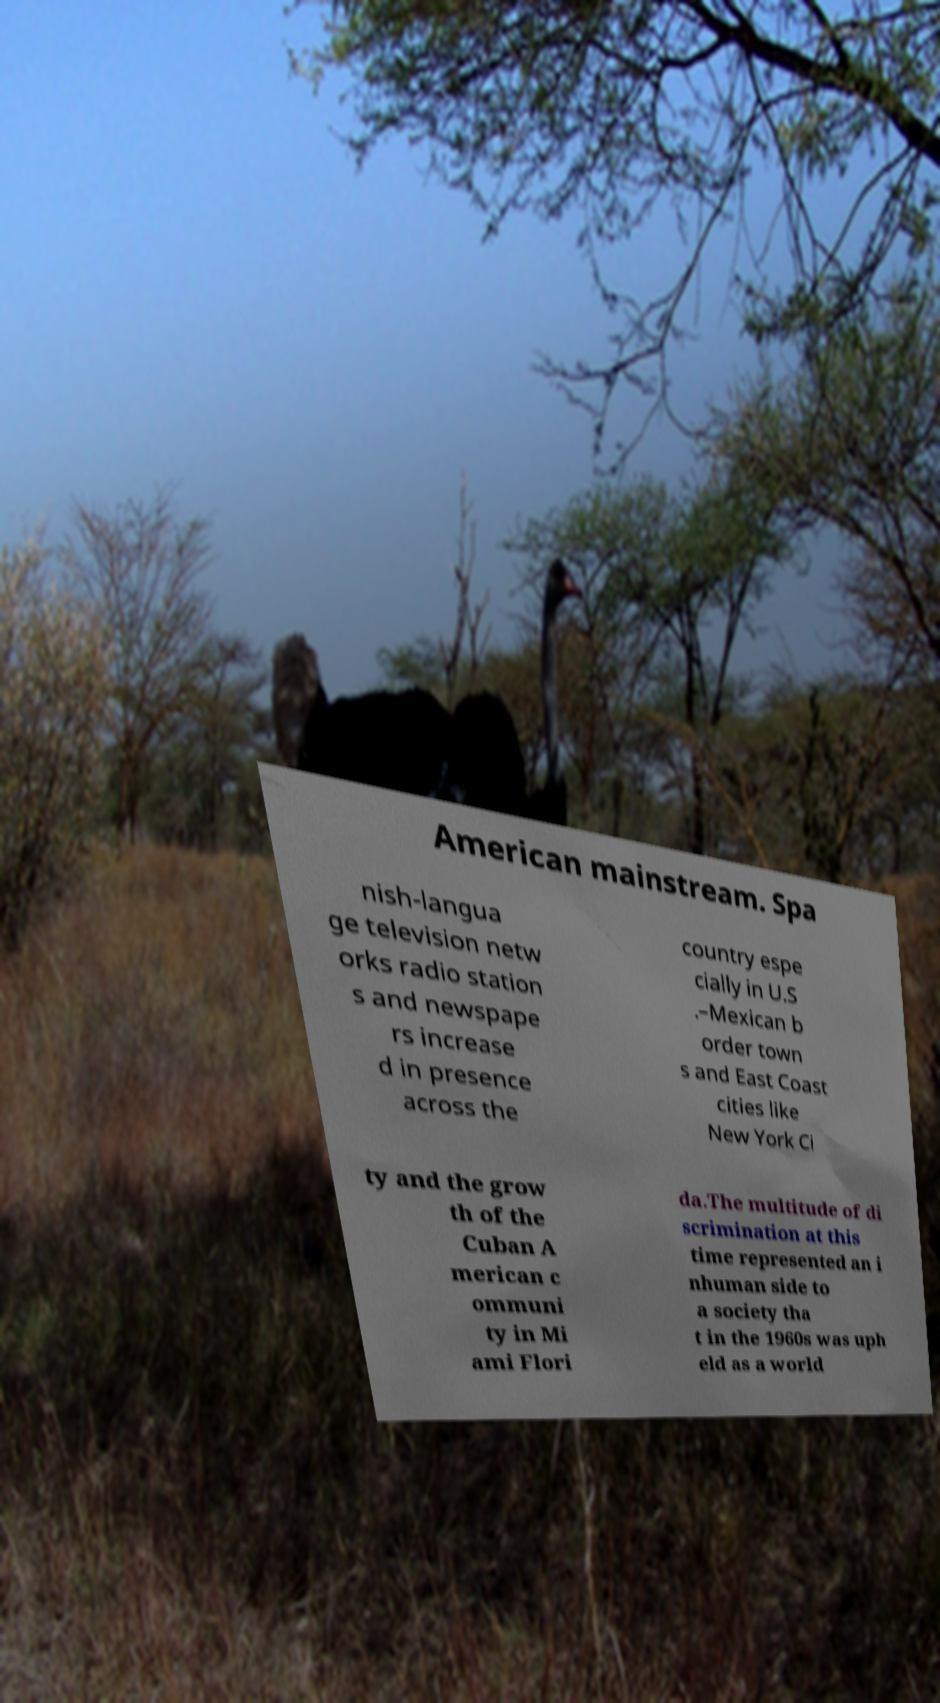Could you assist in decoding the text presented in this image and type it out clearly? American mainstream. Spa nish-langua ge television netw orks radio station s and newspape rs increase d in presence across the country espe cially in U.S .–Mexican b order town s and East Coast cities like New York Ci ty and the grow th of the Cuban A merican c ommuni ty in Mi ami Flori da.The multitude of di scrimination at this time represented an i nhuman side to a society tha t in the 1960s was uph eld as a world 